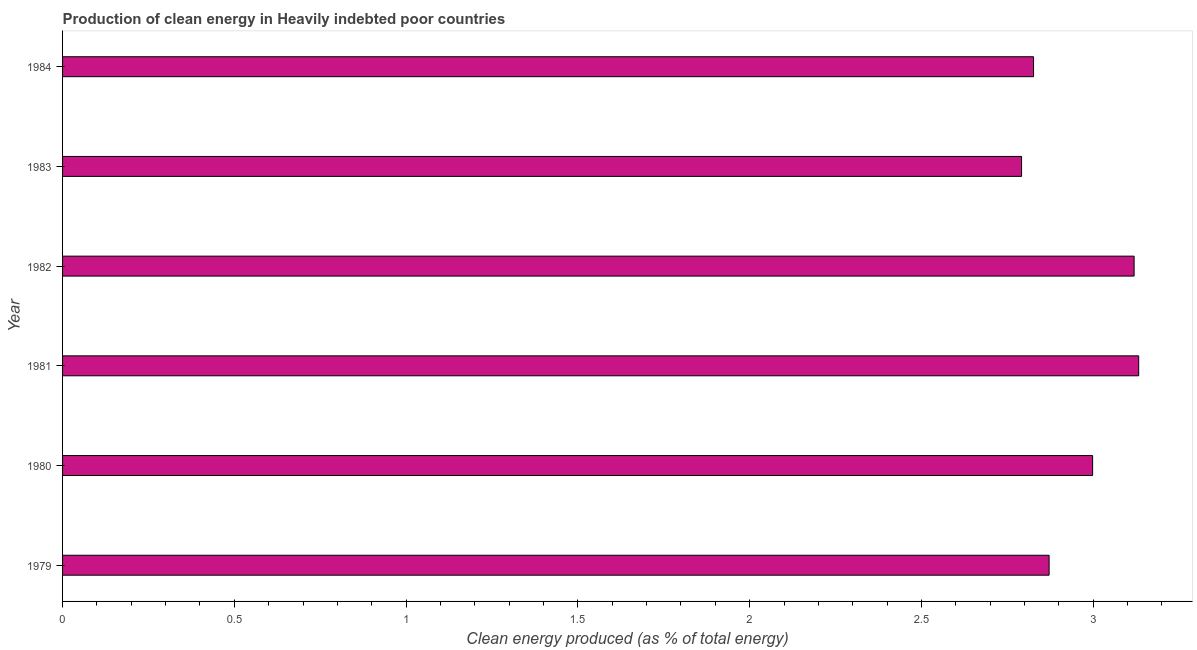Does the graph contain grids?
Your answer should be very brief. No. What is the title of the graph?
Make the answer very short. Production of clean energy in Heavily indebted poor countries. What is the label or title of the X-axis?
Your answer should be very brief. Clean energy produced (as % of total energy). What is the production of clean energy in 1979?
Keep it short and to the point. 2.87. Across all years, what is the maximum production of clean energy?
Ensure brevity in your answer.  3.13. Across all years, what is the minimum production of clean energy?
Keep it short and to the point. 2.79. In which year was the production of clean energy maximum?
Provide a succinct answer. 1981. In which year was the production of clean energy minimum?
Provide a short and direct response. 1983. What is the sum of the production of clean energy?
Ensure brevity in your answer.  17.74. What is the difference between the production of clean energy in 1982 and 1984?
Keep it short and to the point. 0.29. What is the average production of clean energy per year?
Ensure brevity in your answer.  2.96. What is the median production of clean energy?
Offer a very short reply. 2.93. Do a majority of the years between 1983 and 1980 (inclusive) have production of clean energy greater than 1.4 %?
Provide a short and direct response. Yes. What is the ratio of the production of clean energy in 1980 to that in 1984?
Give a very brief answer. 1.06. What is the difference between the highest and the second highest production of clean energy?
Offer a terse response. 0.01. Is the sum of the production of clean energy in 1983 and 1984 greater than the maximum production of clean energy across all years?
Make the answer very short. Yes. What is the difference between the highest and the lowest production of clean energy?
Provide a short and direct response. 0.34. How many bars are there?
Your answer should be very brief. 6. Are all the bars in the graph horizontal?
Provide a short and direct response. Yes. What is the difference between two consecutive major ticks on the X-axis?
Keep it short and to the point. 0.5. What is the Clean energy produced (as % of total energy) of 1979?
Offer a terse response. 2.87. What is the Clean energy produced (as % of total energy) in 1980?
Ensure brevity in your answer.  3. What is the Clean energy produced (as % of total energy) of 1981?
Offer a very short reply. 3.13. What is the Clean energy produced (as % of total energy) of 1982?
Your answer should be compact. 3.12. What is the Clean energy produced (as % of total energy) of 1983?
Your response must be concise. 2.79. What is the Clean energy produced (as % of total energy) of 1984?
Give a very brief answer. 2.83. What is the difference between the Clean energy produced (as % of total energy) in 1979 and 1980?
Ensure brevity in your answer.  -0.13. What is the difference between the Clean energy produced (as % of total energy) in 1979 and 1981?
Your answer should be compact. -0.26. What is the difference between the Clean energy produced (as % of total energy) in 1979 and 1982?
Your answer should be very brief. -0.25. What is the difference between the Clean energy produced (as % of total energy) in 1979 and 1983?
Make the answer very short. 0.08. What is the difference between the Clean energy produced (as % of total energy) in 1979 and 1984?
Ensure brevity in your answer.  0.05. What is the difference between the Clean energy produced (as % of total energy) in 1980 and 1981?
Your response must be concise. -0.13. What is the difference between the Clean energy produced (as % of total energy) in 1980 and 1982?
Your answer should be very brief. -0.12. What is the difference between the Clean energy produced (as % of total energy) in 1980 and 1983?
Your answer should be very brief. 0.21. What is the difference between the Clean energy produced (as % of total energy) in 1980 and 1984?
Offer a very short reply. 0.17. What is the difference between the Clean energy produced (as % of total energy) in 1981 and 1982?
Offer a very short reply. 0.01. What is the difference between the Clean energy produced (as % of total energy) in 1981 and 1983?
Keep it short and to the point. 0.34. What is the difference between the Clean energy produced (as % of total energy) in 1981 and 1984?
Provide a short and direct response. 0.31. What is the difference between the Clean energy produced (as % of total energy) in 1982 and 1983?
Your answer should be compact. 0.33. What is the difference between the Clean energy produced (as % of total energy) in 1982 and 1984?
Your answer should be very brief. 0.29. What is the difference between the Clean energy produced (as % of total energy) in 1983 and 1984?
Ensure brevity in your answer.  -0.03. What is the ratio of the Clean energy produced (as % of total energy) in 1979 to that in 1980?
Your answer should be compact. 0.96. What is the ratio of the Clean energy produced (as % of total energy) in 1979 to that in 1981?
Your response must be concise. 0.92. What is the ratio of the Clean energy produced (as % of total energy) in 1979 to that in 1982?
Provide a short and direct response. 0.92. What is the ratio of the Clean energy produced (as % of total energy) in 1979 to that in 1984?
Make the answer very short. 1.02. What is the ratio of the Clean energy produced (as % of total energy) in 1980 to that in 1982?
Provide a short and direct response. 0.96. What is the ratio of the Clean energy produced (as % of total energy) in 1980 to that in 1983?
Provide a succinct answer. 1.07. What is the ratio of the Clean energy produced (as % of total energy) in 1980 to that in 1984?
Make the answer very short. 1.06. What is the ratio of the Clean energy produced (as % of total energy) in 1981 to that in 1983?
Give a very brief answer. 1.12. What is the ratio of the Clean energy produced (as % of total energy) in 1981 to that in 1984?
Provide a short and direct response. 1.11. What is the ratio of the Clean energy produced (as % of total energy) in 1982 to that in 1983?
Ensure brevity in your answer.  1.12. What is the ratio of the Clean energy produced (as % of total energy) in 1982 to that in 1984?
Your response must be concise. 1.1. 